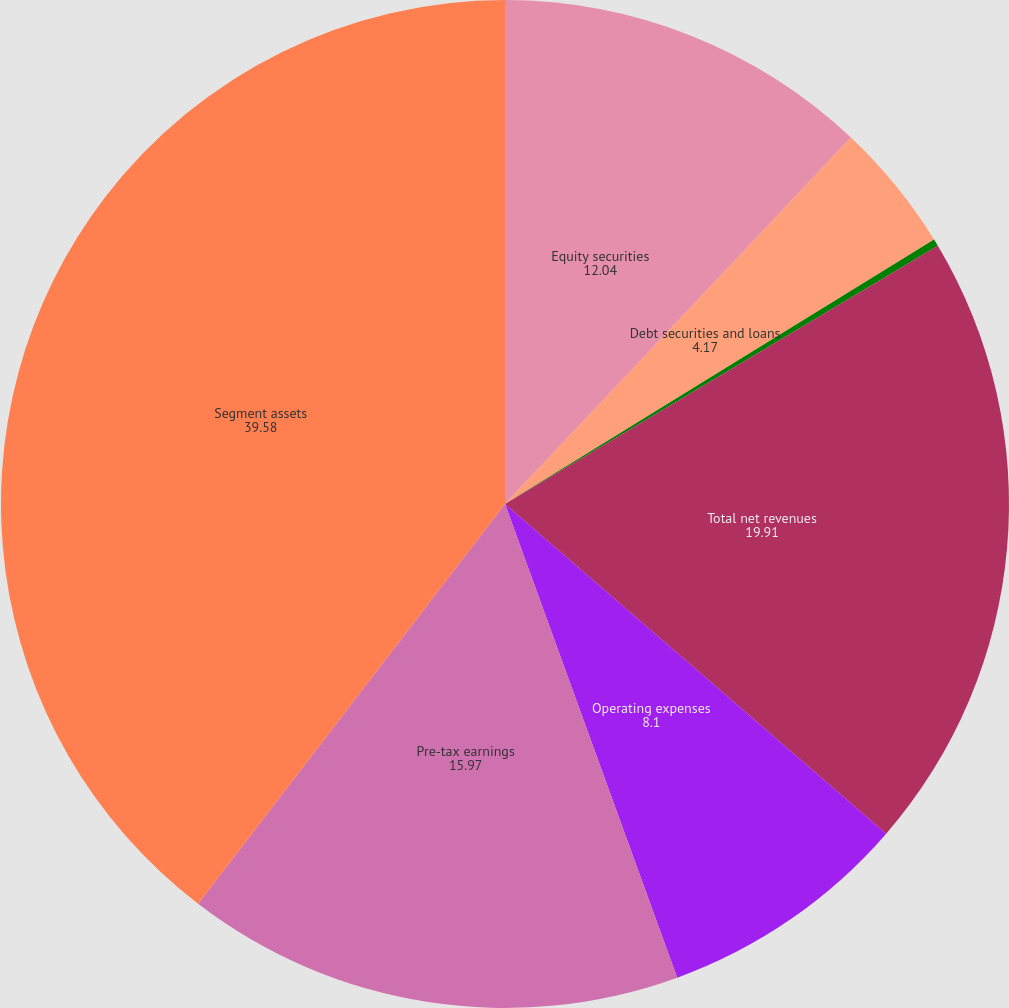<chart> <loc_0><loc_0><loc_500><loc_500><pie_chart><fcel>Equity securities<fcel>Debt securities and loans<fcel>Other<fcel>Total net revenues<fcel>Operating expenses<fcel>Pre-tax earnings<fcel>Segment assets<nl><fcel>12.04%<fcel>4.17%<fcel>0.23%<fcel>19.91%<fcel>8.1%<fcel>15.97%<fcel>39.58%<nl></chart> 